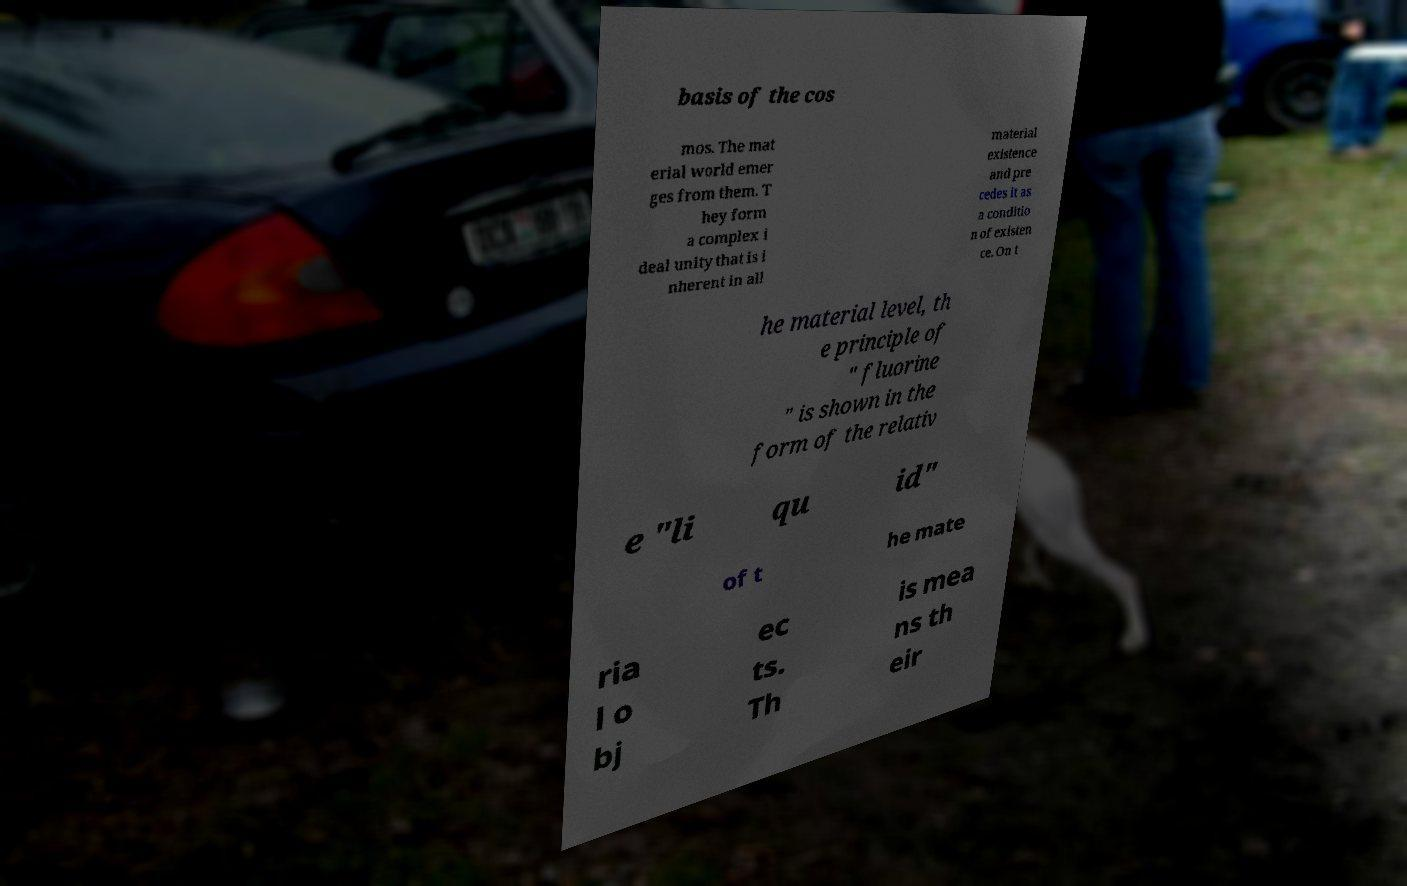Could you extract and type out the text from this image? basis of the cos mos. The mat erial world emer ges from them. T hey form a complex i deal unity that is i nherent in all material existence and pre cedes it as a conditio n of existen ce. On t he material level, th e principle of " fluorine " is shown in the form of the relativ e "li qu id" of t he mate ria l o bj ec ts. Th is mea ns th eir 